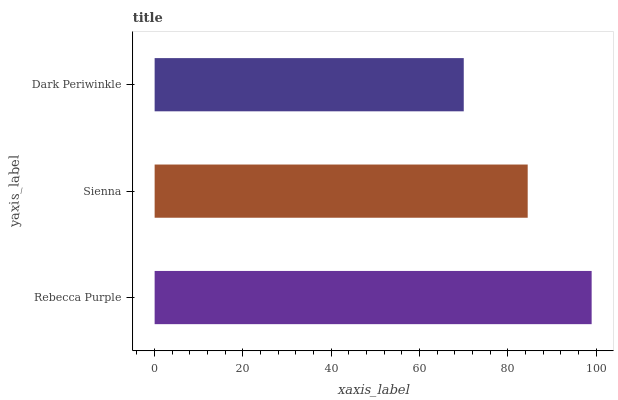Is Dark Periwinkle the minimum?
Answer yes or no. Yes. Is Rebecca Purple the maximum?
Answer yes or no. Yes. Is Sienna the minimum?
Answer yes or no. No. Is Sienna the maximum?
Answer yes or no. No. Is Rebecca Purple greater than Sienna?
Answer yes or no. Yes. Is Sienna less than Rebecca Purple?
Answer yes or no. Yes. Is Sienna greater than Rebecca Purple?
Answer yes or no. No. Is Rebecca Purple less than Sienna?
Answer yes or no. No. Is Sienna the high median?
Answer yes or no. Yes. Is Sienna the low median?
Answer yes or no. Yes. Is Dark Periwinkle the high median?
Answer yes or no. No. Is Dark Periwinkle the low median?
Answer yes or no. No. 